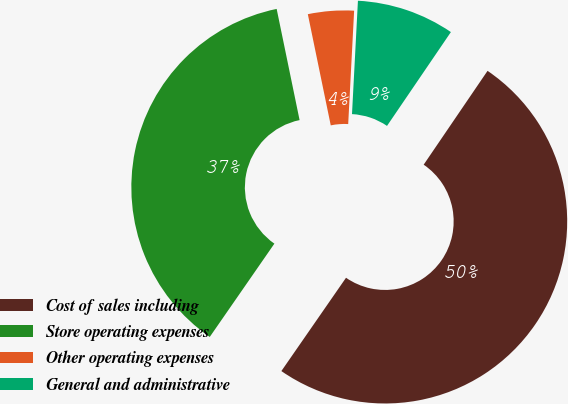<chart> <loc_0><loc_0><loc_500><loc_500><pie_chart><fcel>Cost of sales including<fcel>Store operating expenses<fcel>Other operating expenses<fcel>General and administrative<nl><fcel>50.13%<fcel>37.12%<fcel>4.07%<fcel>8.68%<nl></chart> 